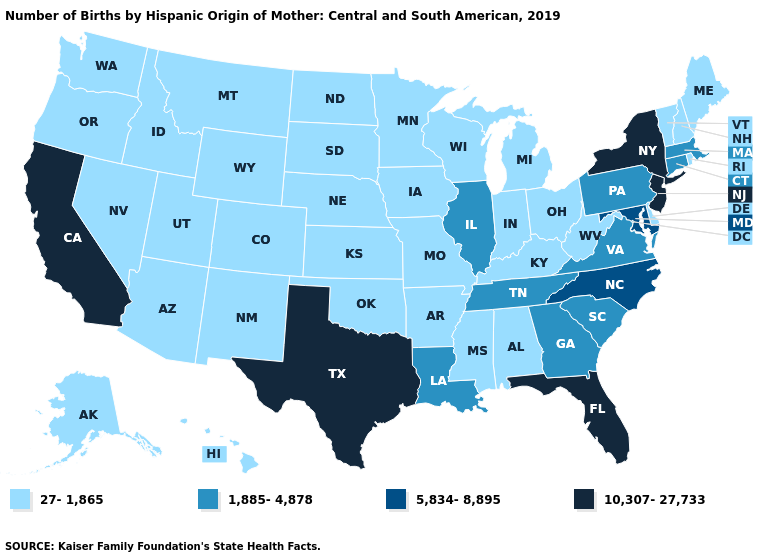Does the first symbol in the legend represent the smallest category?
Be succinct. Yes. Among the states that border New Mexico , which have the highest value?
Write a very short answer. Texas. What is the lowest value in the USA?
Be succinct. 27-1,865. Which states have the lowest value in the South?
Be succinct. Alabama, Arkansas, Delaware, Kentucky, Mississippi, Oklahoma, West Virginia. Among the states that border Missouri , does Tennessee have the lowest value?
Quick response, please. No. What is the value of Colorado?
Answer briefly. 27-1,865. What is the value of Maryland?
Write a very short answer. 5,834-8,895. Does the first symbol in the legend represent the smallest category?
Give a very brief answer. Yes. What is the value of New York?
Keep it brief. 10,307-27,733. Among the states that border Florida , which have the highest value?
Give a very brief answer. Georgia. Does Georgia have a lower value than California?
Concise answer only. Yes. Name the states that have a value in the range 10,307-27,733?
Short answer required. California, Florida, New Jersey, New York, Texas. Among the states that border Tennessee , which have the highest value?
Quick response, please. North Carolina. Which states have the lowest value in the USA?
Be succinct. Alabama, Alaska, Arizona, Arkansas, Colorado, Delaware, Hawaii, Idaho, Indiana, Iowa, Kansas, Kentucky, Maine, Michigan, Minnesota, Mississippi, Missouri, Montana, Nebraska, Nevada, New Hampshire, New Mexico, North Dakota, Ohio, Oklahoma, Oregon, Rhode Island, South Dakota, Utah, Vermont, Washington, West Virginia, Wisconsin, Wyoming. 